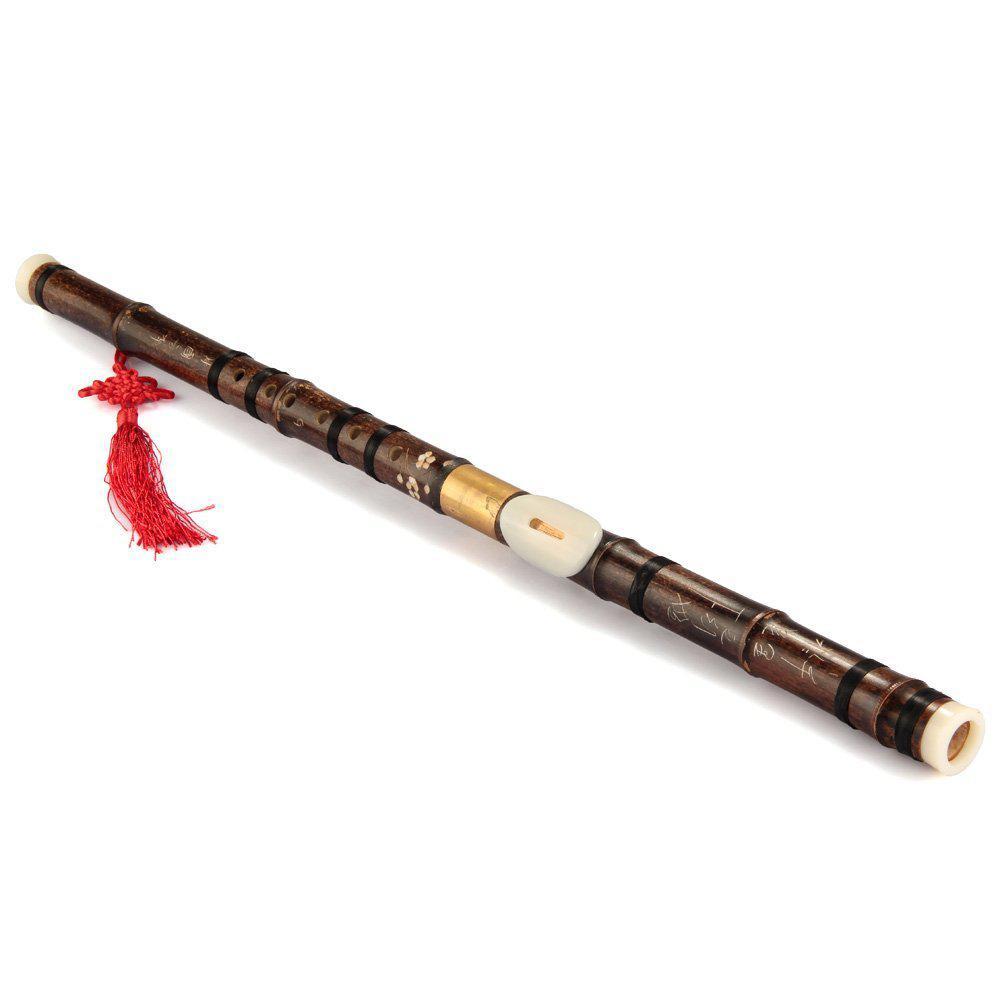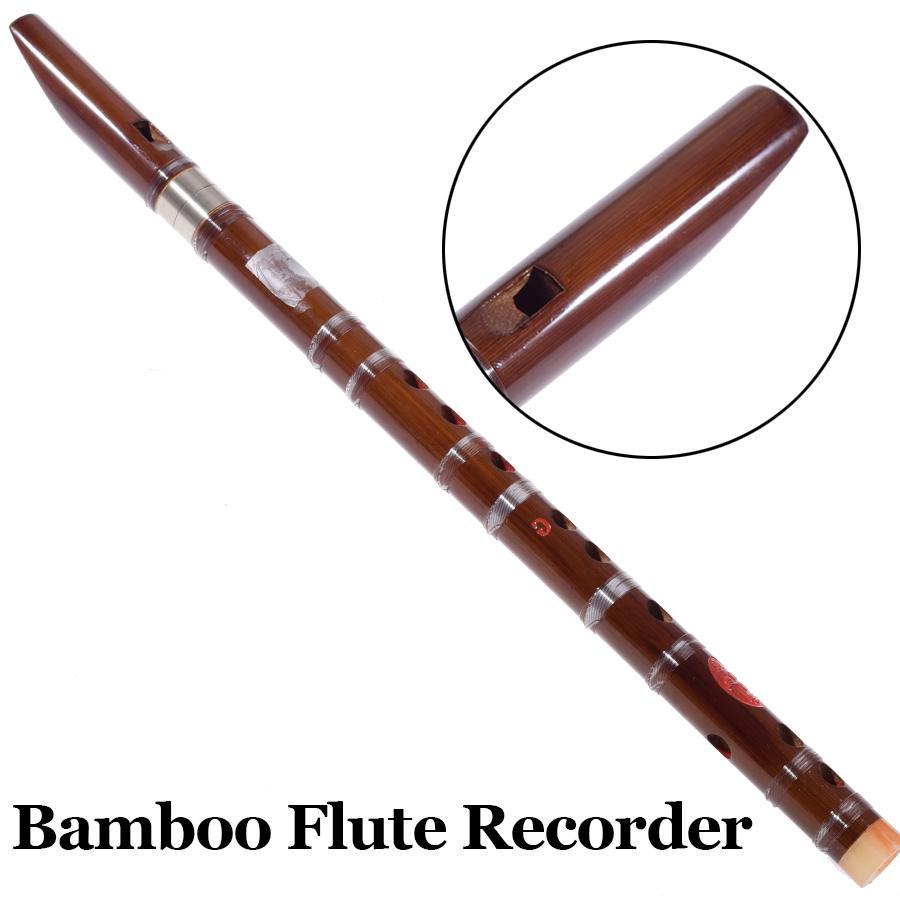The first image is the image on the left, the second image is the image on the right. Assess this claim about the two images: "There are exactly four wooden cylinders.". Correct or not? Answer yes or no. No. The first image is the image on the left, the second image is the image on the right. Assess this claim about the two images: "The combined images contain one straight black flute with a flared end, one complete wooden flute, and two flute pieces displayed with one end close together.". Correct or not? Answer yes or no. No. 